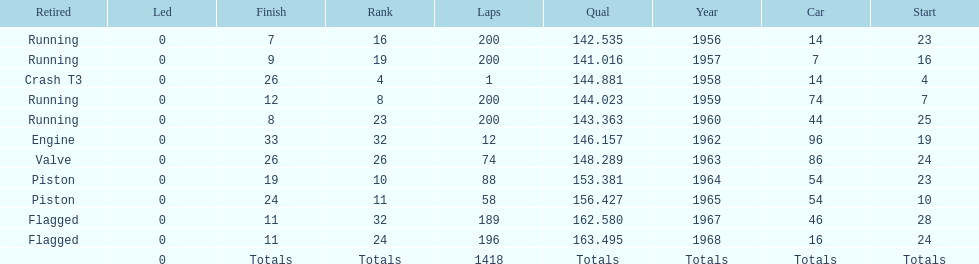Tell me the number of times he finished above 10th place. 3. 